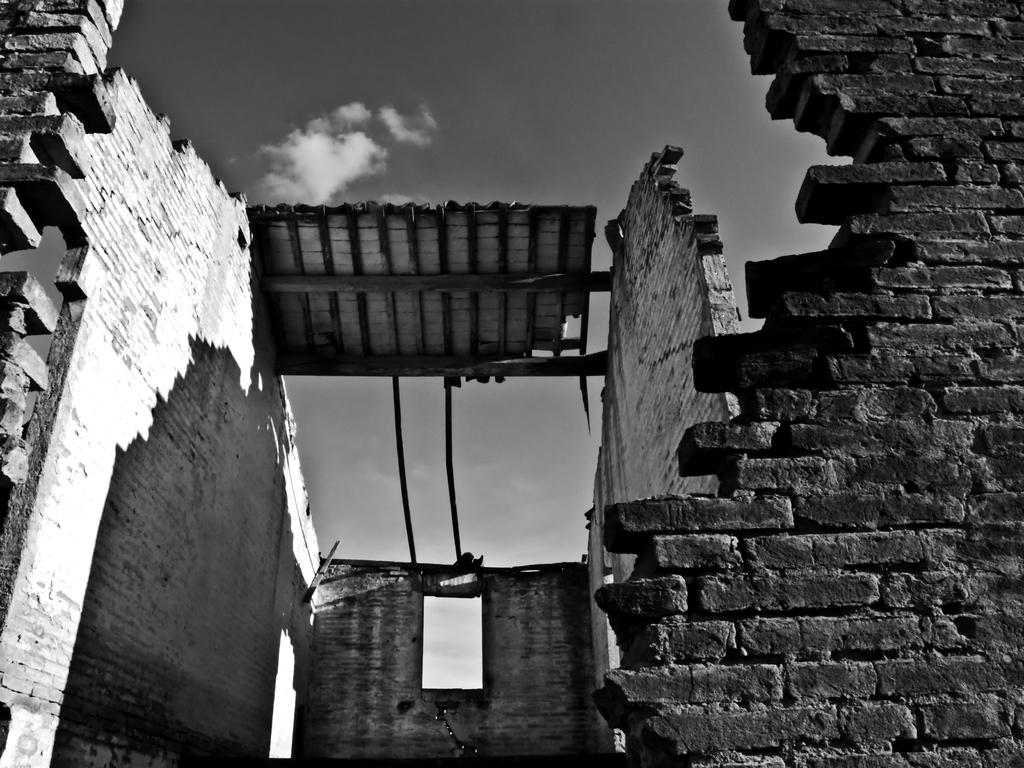What type of structure is in the image? There is an old building in the image. What are some of the main features of the image? The image contains walls and a sky visible in the background. What is the color scheme of the image? The image is black and white. What is the government discussing in the image? There is no indication of a government or any discussion taking place in the image. 